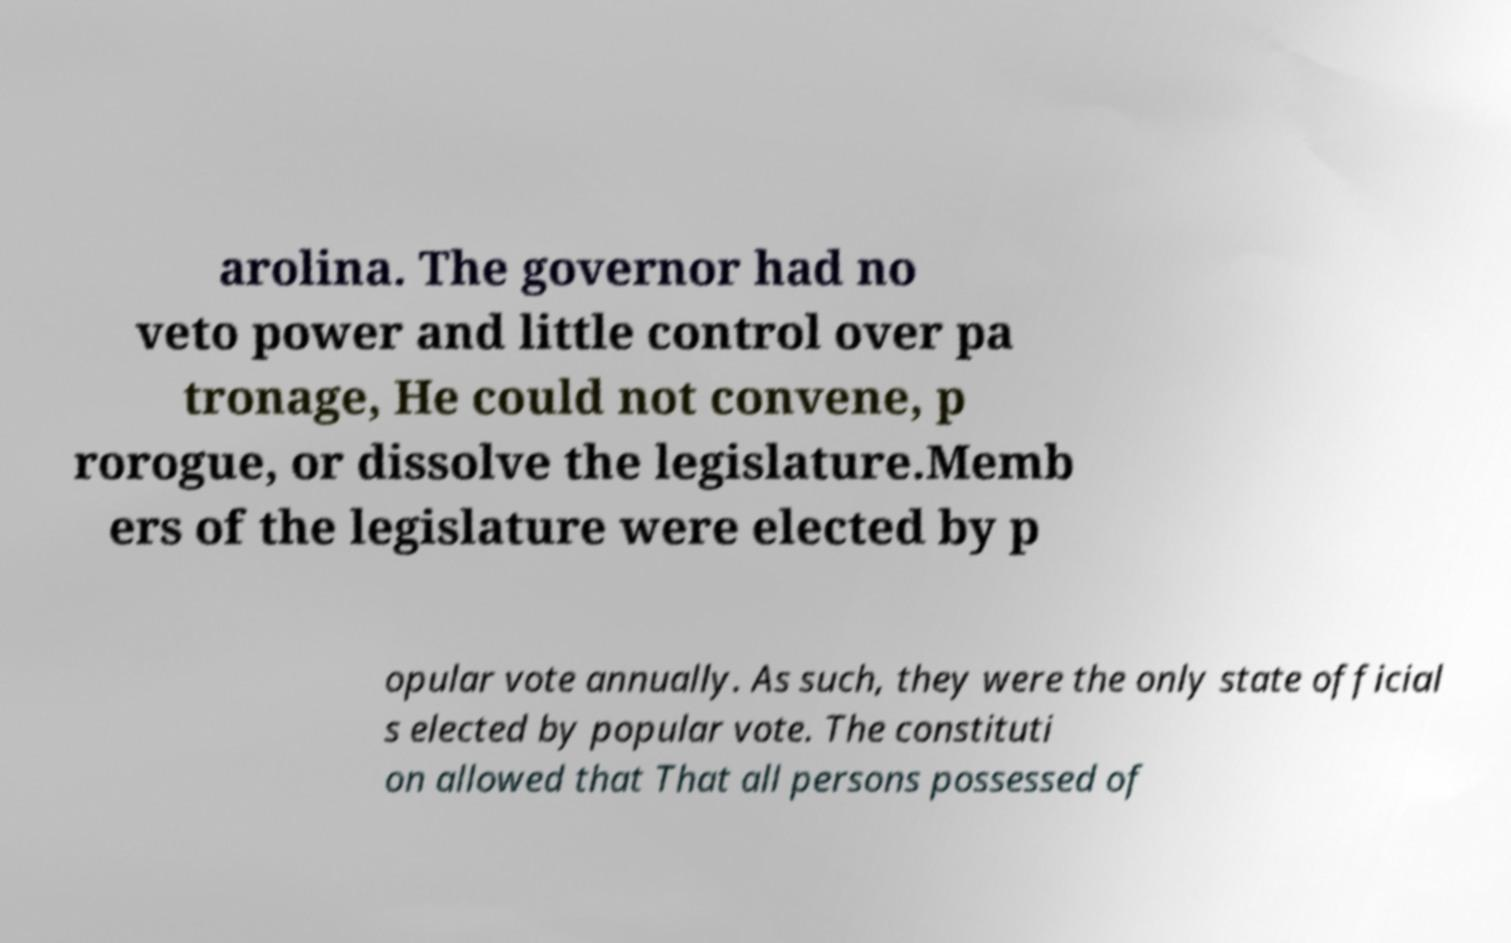What messages or text are displayed in this image? I need them in a readable, typed format. arolina. The governor had no veto power and little control over pa tronage, He could not convene, p rorogue, or dissolve the legislature.Memb ers of the legislature were elected by p opular vote annually. As such, they were the only state official s elected by popular vote. The constituti on allowed that That all persons possessed of 